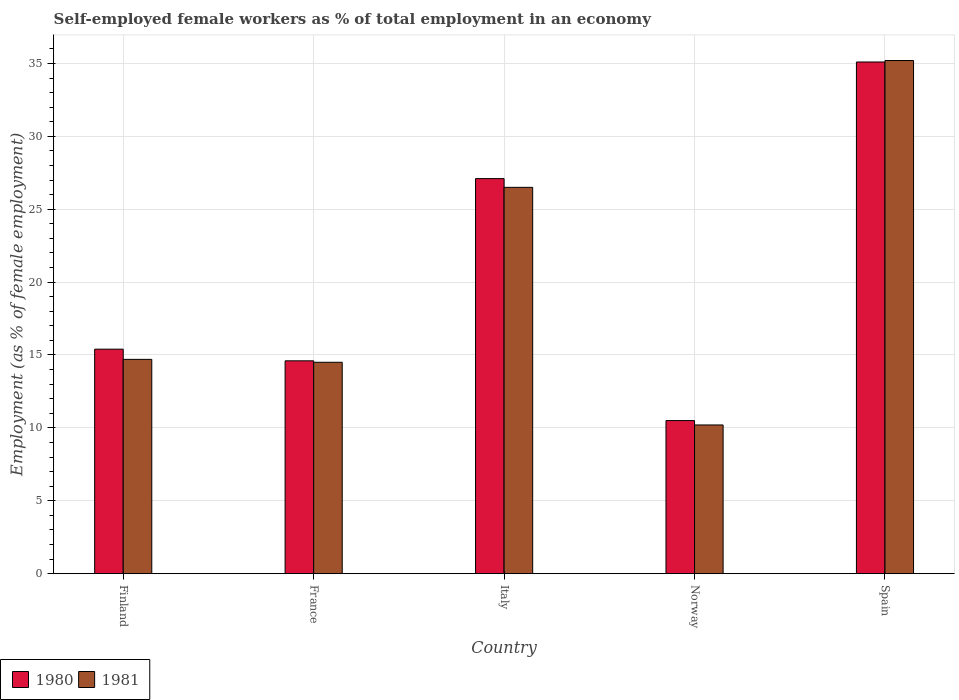How many different coloured bars are there?
Make the answer very short. 2. How many groups of bars are there?
Offer a very short reply. 5. Are the number of bars per tick equal to the number of legend labels?
Make the answer very short. Yes. How many bars are there on the 2nd tick from the right?
Your answer should be compact. 2. What is the percentage of self-employed female workers in 1981 in Spain?
Offer a terse response. 35.2. Across all countries, what is the maximum percentage of self-employed female workers in 1981?
Provide a succinct answer. 35.2. Across all countries, what is the minimum percentage of self-employed female workers in 1981?
Give a very brief answer. 10.2. In which country was the percentage of self-employed female workers in 1980 maximum?
Provide a succinct answer. Spain. In which country was the percentage of self-employed female workers in 1981 minimum?
Provide a short and direct response. Norway. What is the total percentage of self-employed female workers in 1981 in the graph?
Provide a succinct answer. 101.1. What is the difference between the percentage of self-employed female workers in 1981 in France and that in Italy?
Your answer should be very brief. -12. What is the difference between the percentage of self-employed female workers in 1981 in Norway and the percentage of self-employed female workers in 1980 in Finland?
Keep it short and to the point. -5.2. What is the average percentage of self-employed female workers in 1980 per country?
Your answer should be compact. 20.54. What is the difference between the percentage of self-employed female workers of/in 1980 and percentage of self-employed female workers of/in 1981 in Finland?
Your answer should be compact. 0.7. What is the ratio of the percentage of self-employed female workers in 1980 in Italy to that in Spain?
Provide a succinct answer. 0.77. Is the difference between the percentage of self-employed female workers in 1980 in Finland and Italy greater than the difference between the percentage of self-employed female workers in 1981 in Finland and Italy?
Offer a terse response. Yes. What is the difference between the highest and the second highest percentage of self-employed female workers in 1980?
Offer a very short reply. -8. What is the difference between the highest and the lowest percentage of self-employed female workers in 1980?
Provide a succinct answer. 24.6. In how many countries, is the percentage of self-employed female workers in 1980 greater than the average percentage of self-employed female workers in 1980 taken over all countries?
Give a very brief answer. 2. Is the sum of the percentage of self-employed female workers in 1981 in France and Norway greater than the maximum percentage of self-employed female workers in 1980 across all countries?
Keep it short and to the point. No. How many bars are there?
Your response must be concise. 10. Are all the bars in the graph horizontal?
Your response must be concise. No. Are the values on the major ticks of Y-axis written in scientific E-notation?
Offer a terse response. No. Where does the legend appear in the graph?
Offer a terse response. Bottom left. How many legend labels are there?
Keep it short and to the point. 2. What is the title of the graph?
Provide a succinct answer. Self-employed female workers as % of total employment in an economy. What is the label or title of the Y-axis?
Provide a succinct answer. Employment (as % of female employment). What is the Employment (as % of female employment) in 1980 in Finland?
Your answer should be very brief. 15.4. What is the Employment (as % of female employment) of 1981 in Finland?
Offer a very short reply. 14.7. What is the Employment (as % of female employment) of 1980 in France?
Provide a succinct answer. 14.6. What is the Employment (as % of female employment) in 1981 in France?
Give a very brief answer. 14.5. What is the Employment (as % of female employment) of 1980 in Italy?
Give a very brief answer. 27.1. What is the Employment (as % of female employment) of 1981 in Norway?
Your answer should be compact. 10.2. What is the Employment (as % of female employment) of 1980 in Spain?
Your answer should be very brief. 35.1. What is the Employment (as % of female employment) of 1981 in Spain?
Make the answer very short. 35.2. Across all countries, what is the maximum Employment (as % of female employment) of 1980?
Your answer should be very brief. 35.1. Across all countries, what is the maximum Employment (as % of female employment) of 1981?
Offer a terse response. 35.2. Across all countries, what is the minimum Employment (as % of female employment) in 1981?
Ensure brevity in your answer.  10.2. What is the total Employment (as % of female employment) of 1980 in the graph?
Provide a succinct answer. 102.7. What is the total Employment (as % of female employment) in 1981 in the graph?
Your answer should be very brief. 101.1. What is the difference between the Employment (as % of female employment) in 1980 in Finland and that in France?
Your response must be concise. 0.8. What is the difference between the Employment (as % of female employment) in 1981 in Finland and that in France?
Your answer should be very brief. 0.2. What is the difference between the Employment (as % of female employment) of 1980 in Finland and that in Spain?
Offer a very short reply. -19.7. What is the difference between the Employment (as % of female employment) in 1981 in Finland and that in Spain?
Your answer should be compact. -20.5. What is the difference between the Employment (as % of female employment) of 1980 in France and that in Italy?
Offer a terse response. -12.5. What is the difference between the Employment (as % of female employment) in 1980 in France and that in Spain?
Make the answer very short. -20.5. What is the difference between the Employment (as % of female employment) of 1981 in France and that in Spain?
Your answer should be compact. -20.7. What is the difference between the Employment (as % of female employment) in 1980 in Italy and that in Spain?
Give a very brief answer. -8. What is the difference between the Employment (as % of female employment) of 1980 in Norway and that in Spain?
Give a very brief answer. -24.6. What is the difference between the Employment (as % of female employment) of 1980 in Finland and the Employment (as % of female employment) of 1981 in France?
Provide a short and direct response. 0.9. What is the difference between the Employment (as % of female employment) of 1980 in Finland and the Employment (as % of female employment) of 1981 in Italy?
Make the answer very short. -11.1. What is the difference between the Employment (as % of female employment) of 1980 in Finland and the Employment (as % of female employment) of 1981 in Norway?
Provide a succinct answer. 5.2. What is the difference between the Employment (as % of female employment) in 1980 in Finland and the Employment (as % of female employment) in 1981 in Spain?
Ensure brevity in your answer.  -19.8. What is the difference between the Employment (as % of female employment) in 1980 in France and the Employment (as % of female employment) in 1981 in Spain?
Offer a terse response. -20.6. What is the difference between the Employment (as % of female employment) in 1980 in Italy and the Employment (as % of female employment) in 1981 in Norway?
Offer a terse response. 16.9. What is the difference between the Employment (as % of female employment) of 1980 in Italy and the Employment (as % of female employment) of 1981 in Spain?
Make the answer very short. -8.1. What is the difference between the Employment (as % of female employment) of 1980 in Norway and the Employment (as % of female employment) of 1981 in Spain?
Keep it short and to the point. -24.7. What is the average Employment (as % of female employment) of 1980 per country?
Provide a short and direct response. 20.54. What is the average Employment (as % of female employment) of 1981 per country?
Your answer should be very brief. 20.22. What is the difference between the Employment (as % of female employment) of 1980 and Employment (as % of female employment) of 1981 in France?
Offer a very short reply. 0.1. What is the difference between the Employment (as % of female employment) in 1980 and Employment (as % of female employment) in 1981 in Spain?
Make the answer very short. -0.1. What is the ratio of the Employment (as % of female employment) in 1980 in Finland to that in France?
Offer a very short reply. 1.05. What is the ratio of the Employment (as % of female employment) in 1981 in Finland to that in France?
Your response must be concise. 1.01. What is the ratio of the Employment (as % of female employment) in 1980 in Finland to that in Italy?
Your answer should be compact. 0.57. What is the ratio of the Employment (as % of female employment) of 1981 in Finland to that in Italy?
Ensure brevity in your answer.  0.55. What is the ratio of the Employment (as % of female employment) of 1980 in Finland to that in Norway?
Ensure brevity in your answer.  1.47. What is the ratio of the Employment (as % of female employment) of 1981 in Finland to that in Norway?
Your answer should be very brief. 1.44. What is the ratio of the Employment (as % of female employment) of 1980 in Finland to that in Spain?
Give a very brief answer. 0.44. What is the ratio of the Employment (as % of female employment) in 1981 in Finland to that in Spain?
Your response must be concise. 0.42. What is the ratio of the Employment (as % of female employment) in 1980 in France to that in Italy?
Give a very brief answer. 0.54. What is the ratio of the Employment (as % of female employment) in 1981 in France to that in Italy?
Your answer should be very brief. 0.55. What is the ratio of the Employment (as % of female employment) of 1980 in France to that in Norway?
Your answer should be compact. 1.39. What is the ratio of the Employment (as % of female employment) of 1981 in France to that in Norway?
Give a very brief answer. 1.42. What is the ratio of the Employment (as % of female employment) of 1980 in France to that in Spain?
Keep it short and to the point. 0.42. What is the ratio of the Employment (as % of female employment) in 1981 in France to that in Spain?
Offer a terse response. 0.41. What is the ratio of the Employment (as % of female employment) of 1980 in Italy to that in Norway?
Offer a very short reply. 2.58. What is the ratio of the Employment (as % of female employment) in 1981 in Italy to that in Norway?
Offer a very short reply. 2.6. What is the ratio of the Employment (as % of female employment) in 1980 in Italy to that in Spain?
Provide a succinct answer. 0.77. What is the ratio of the Employment (as % of female employment) in 1981 in Italy to that in Spain?
Your response must be concise. 0.75. What is the ratio of the Employment (as % of female employment) in 1980 in Norway to that in Spain?
Provide a short and direct response. 0.3. What is the ratio of the Employment (as % of female employment) in 1981 in Norway to that in Spain?
Make the answer very short. 0.29. What is the difference between the highest and the second highest Employment (as % of female employment) of 1980?
Give a very brief answer. 8. What is the difference between the highest and the second highest Employment (as % of female employment) of 1981?
Make the answer very short. 8.7. What is the difference between the highest and the lowest Employment (as % of female employment) of 1980?
Make the answer very short. 24.6. 